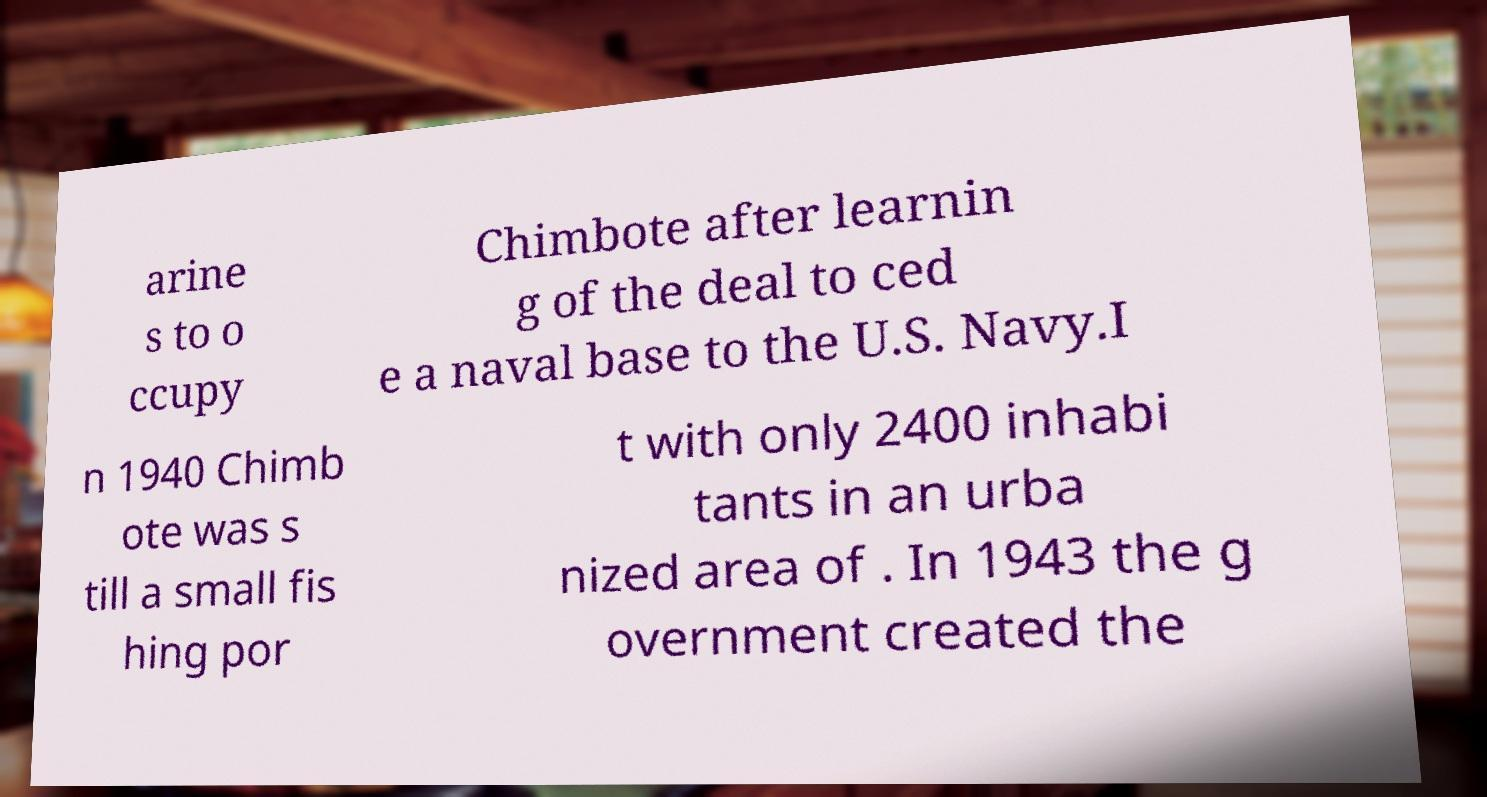Can you read and provide the text displayed in the image?This photo seems to have some interesting text. Can you extract and type it out for me? arine s to o ccupy Chimbote after learnin g of the deal to ced e a naval base to the U.S. Navy.I n 1940 Chimb ote was s till a small fis hing por t with only 2400 inhabi tants in an urba nized area of . In 1943 the g overnment created the 